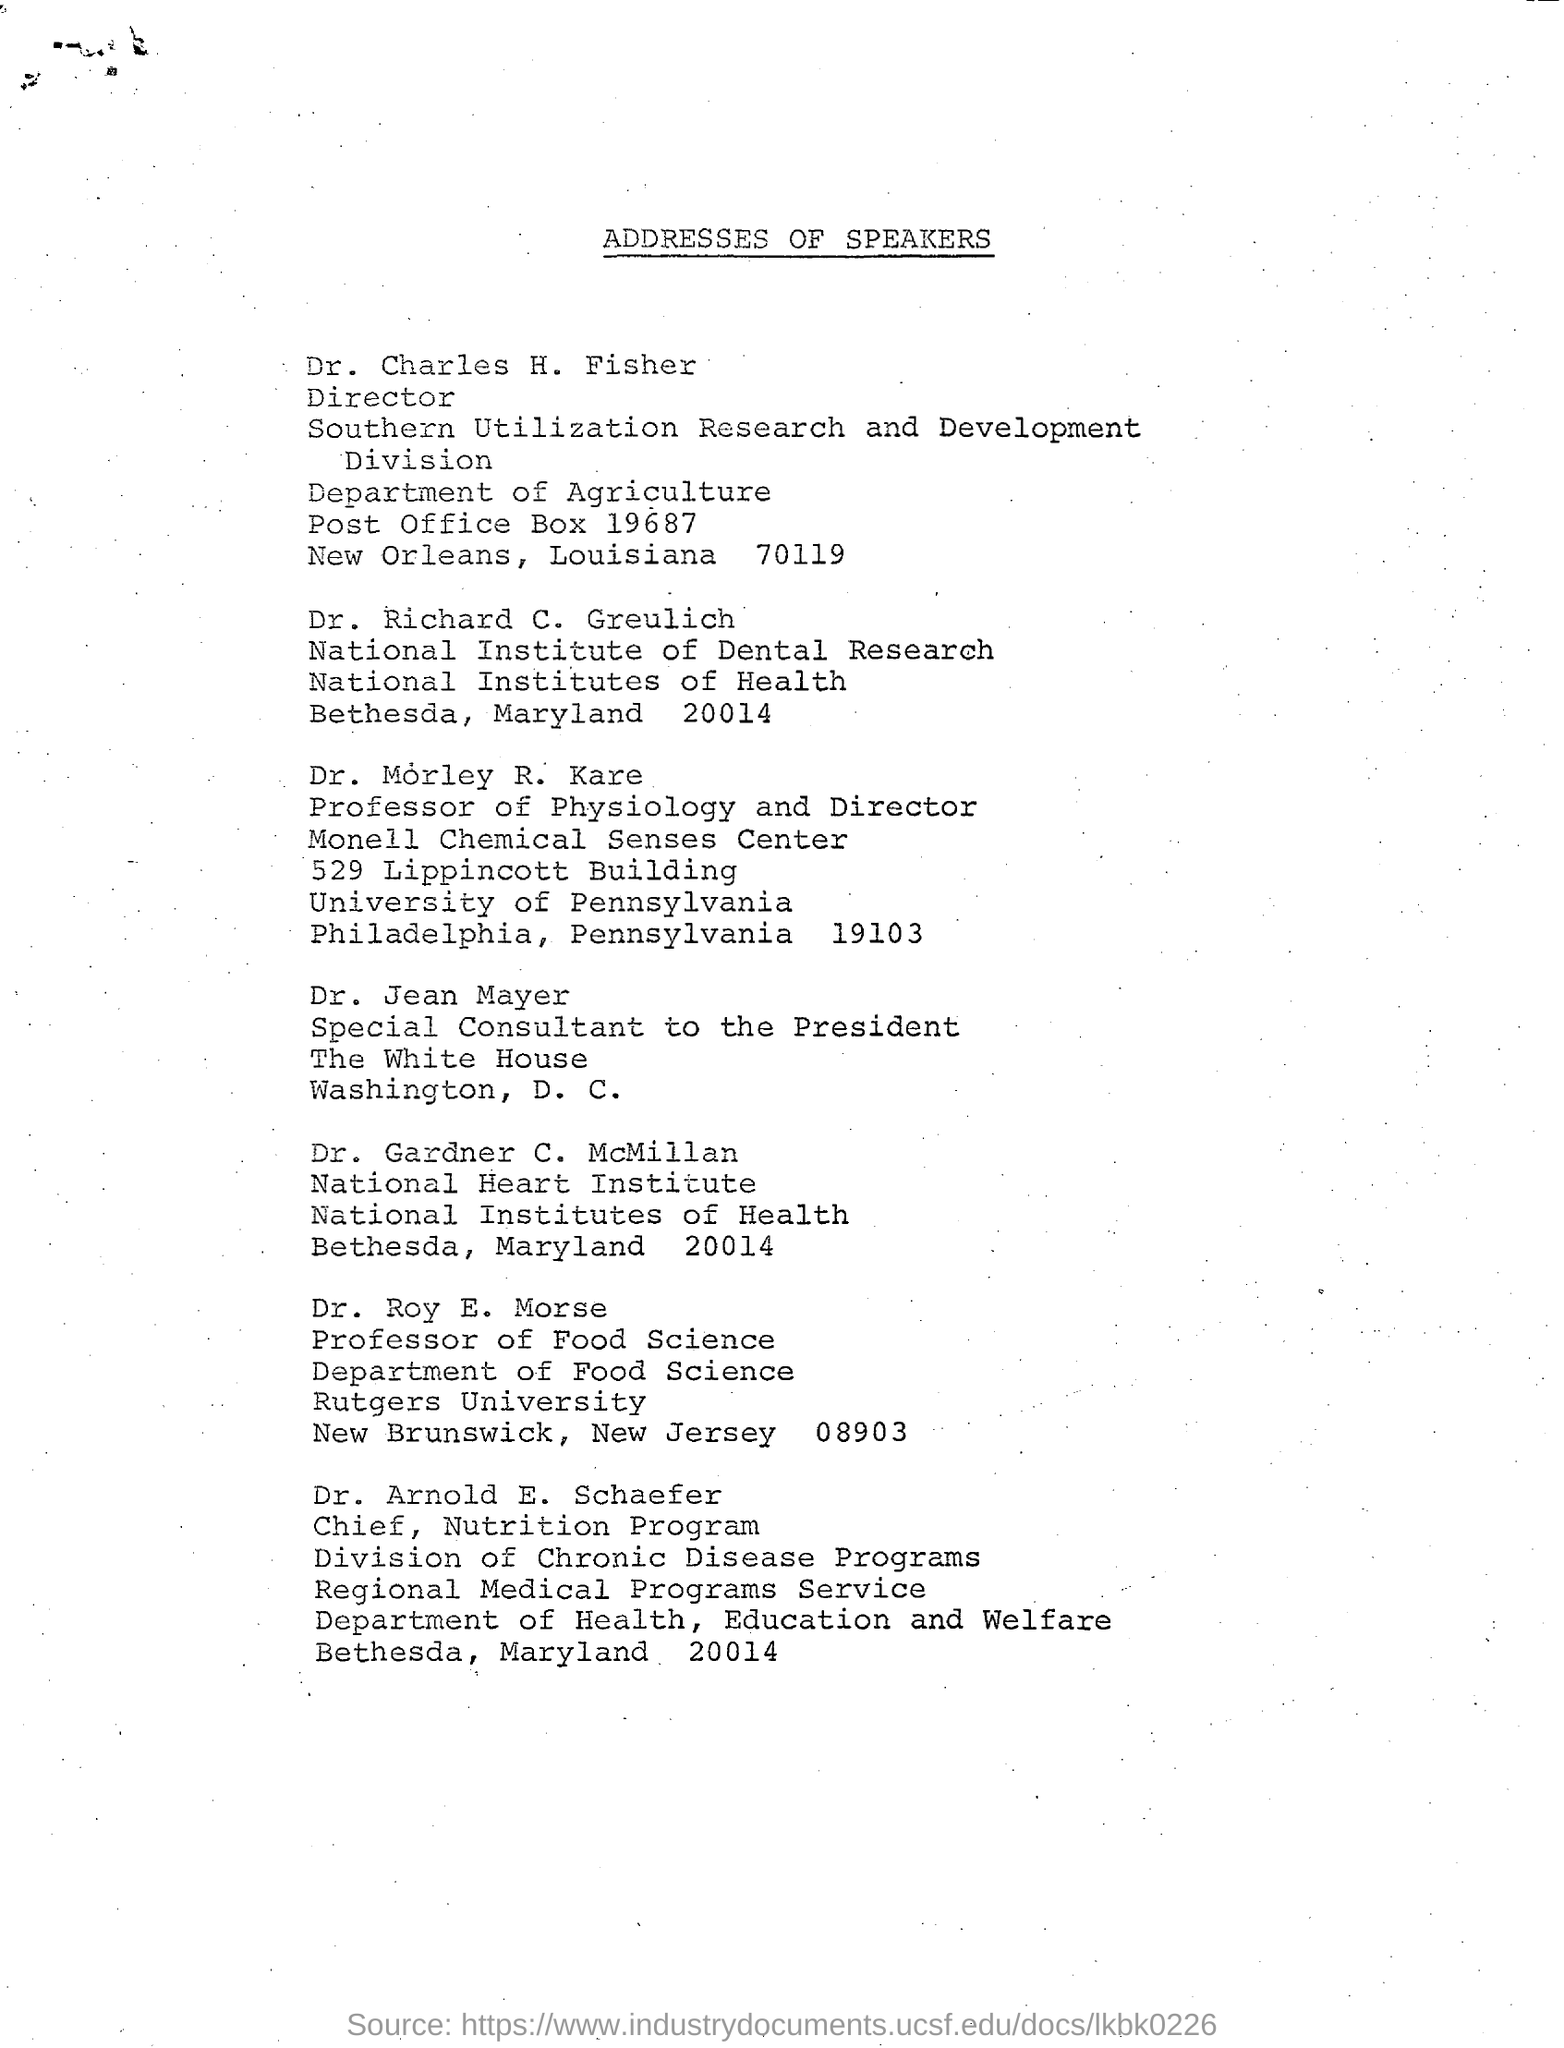What is the title of the document?
Keep it short and to the point. Addresses of Speakers. What is the designation of Dr.Jean Mayer?
Provide a succinct answer. Special consultant to the President. What is the designation of Roy E. Morse?
Offer a terse response. Professor of food Science. 